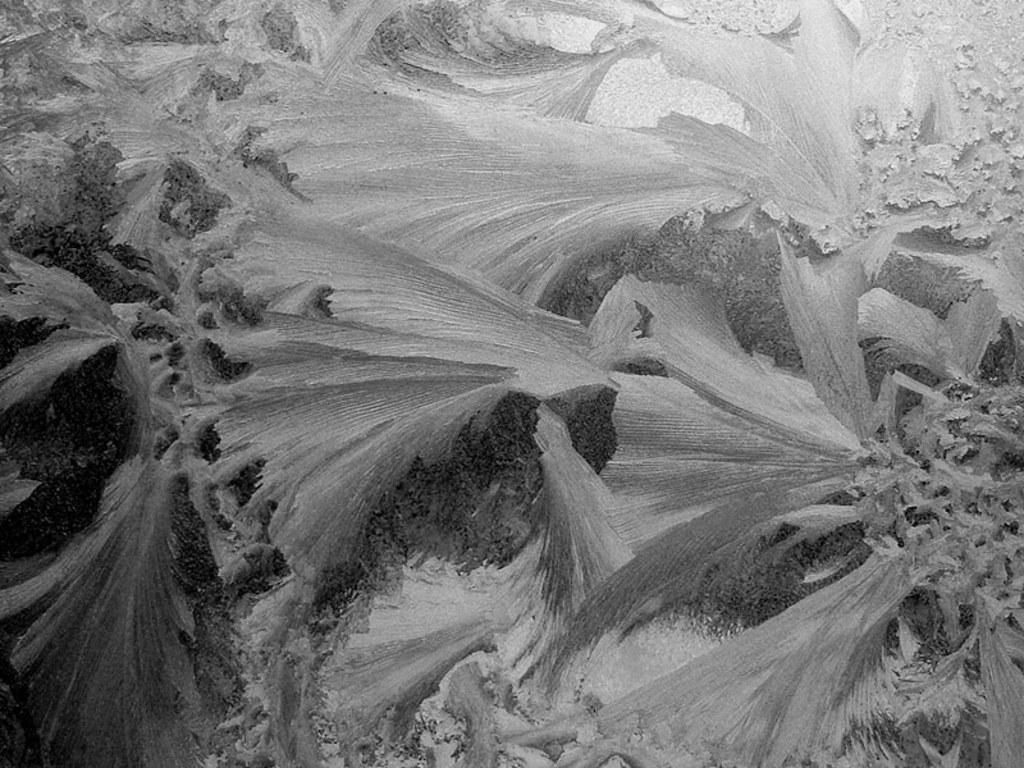How would you summarize this image in a sentence or two? This is a black and white picture and in this picture we can see plants. 